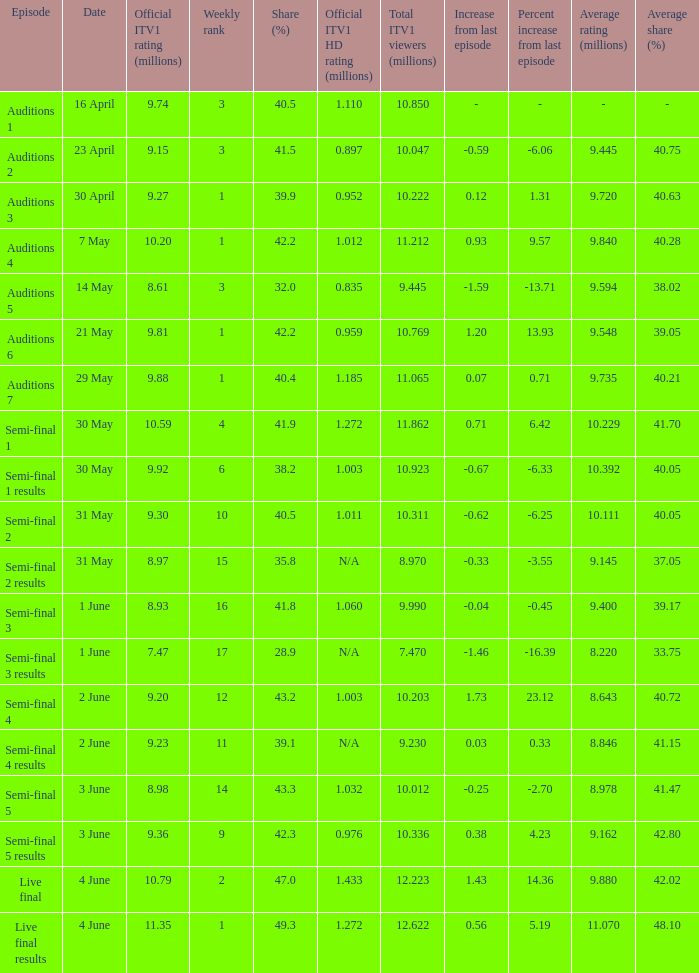Which episode had an official ITV1 HD rating of 1.185 million?  Auditions 7. 